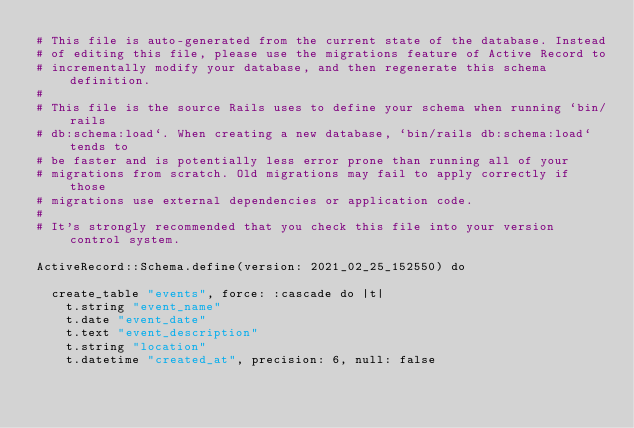Convert code to text. <code><loc_0><loc_0><loc_500><loc_500><_Ruby_># This file is auto-generated from the current state of the database. Instead
# of editing this file, please use the migrations feature of Active Record to
# incrementally modify your database, and then regenerate this schema definition.
#
# This file is the source Rails uses to define your schema when running `bin/rails
# db:schema:load`. When creating a new database, `bin/rails db:schema:load` tends to
# be faster and is potentially less error prone than running all of your
# migrations from scratch. Old migrations may fail to apply correctly if those
# migrations use external dependencies or application code.
#
# It's strongly recommended that you check this file into your version control system.

ActiveRecord::Schema.define(version: 2021_02_25_152550) do

  create_table "events", force: :cascade do |t|
    t.string "event_name"
    t.date "event_date"
    t.text "event_description"
    t.string "location"
    t.datetime "created_at", precision: 6, null: false</code> 